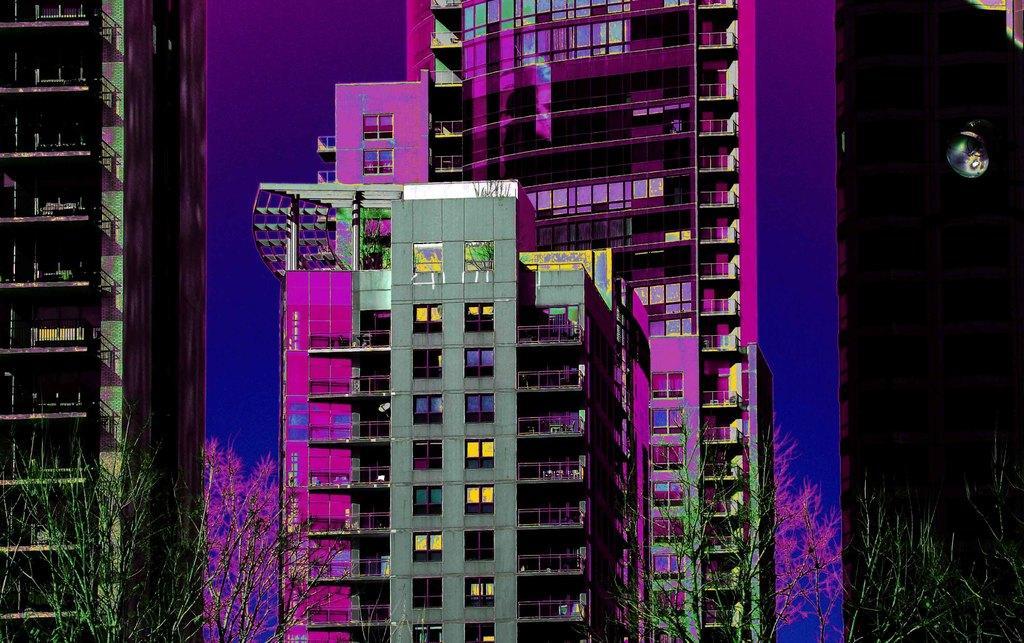In one or two sentences, can you explain what this image depicts? It is an edited picture. In this image, we can see buildings, trees, walls and railings. 